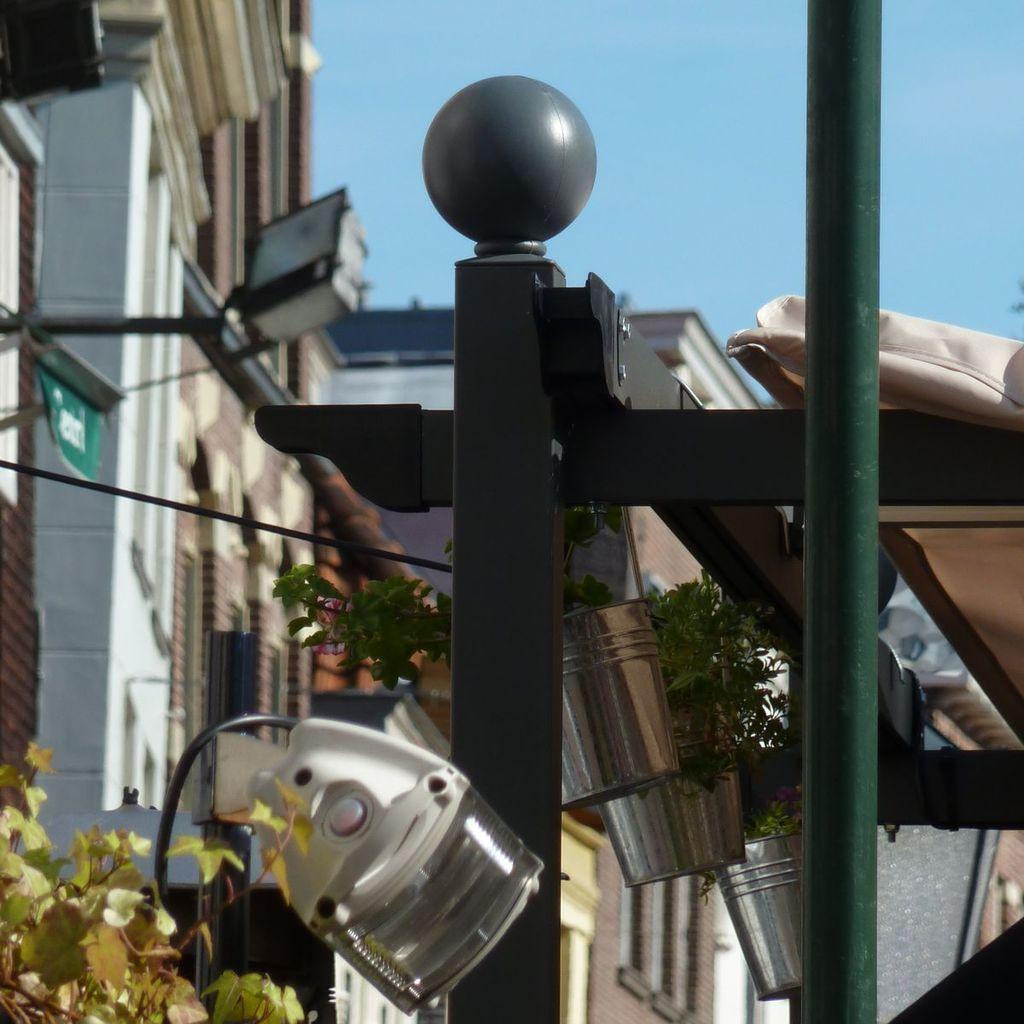Where was the image taken? The image was clicked outside. What can be seen in the middle of the image? There are plants and buildings in the middle of the image. What is visible at the top of the image? The sky is visible at the top of the image. What type of lighting is present at the bottom of the image? There is light at the bottom of the image. What type of record can be seen spinning on a turntable in the image? There is no record or turntable present in the image. Can you see an airplane flying in the sky in the image? The image does not show an airplane flying in the sky. 